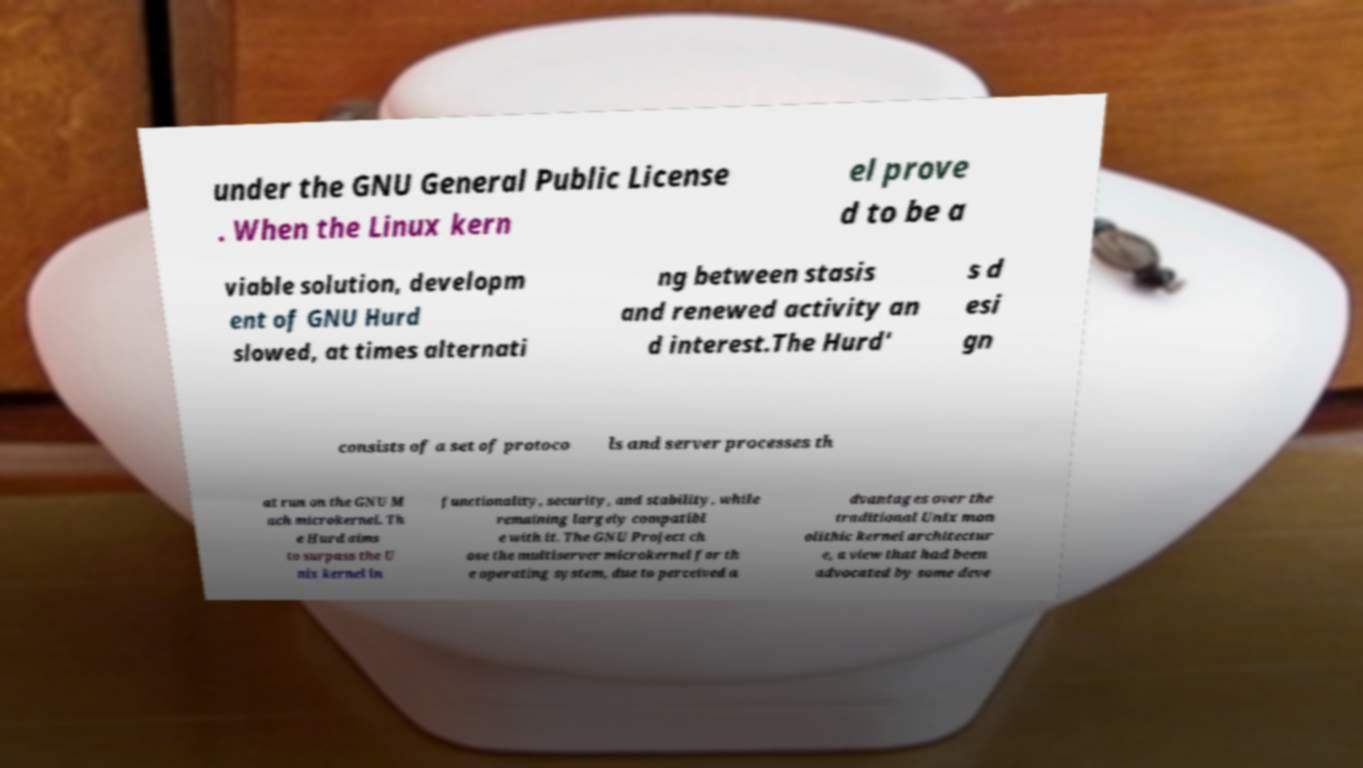Can you read and provide the text displayed in the image?This photo seems to have some interesting text. Can you extract and type it out for me? under the GNU General Public License . When the Linux kern el prove d to be a viable solution, developm ent of GNU Hurd slowed, at times alternati ng between stasis and renewed activity an d interest.The Hurd' s d esi gn consists of a set of protoco ls and server processes th at run on the GNU M ach microkernel. Th e Hurd aims to surpass the U nix kernel in functionality, security, and stability, while remaining largely compatibl e with it. The GNU Project ch ose the multiserver microkernel for th e operating system, due to perceived a dvantages over the traditional Unix mon olithic kernel architectur e, a view that had been advocated by some deve 